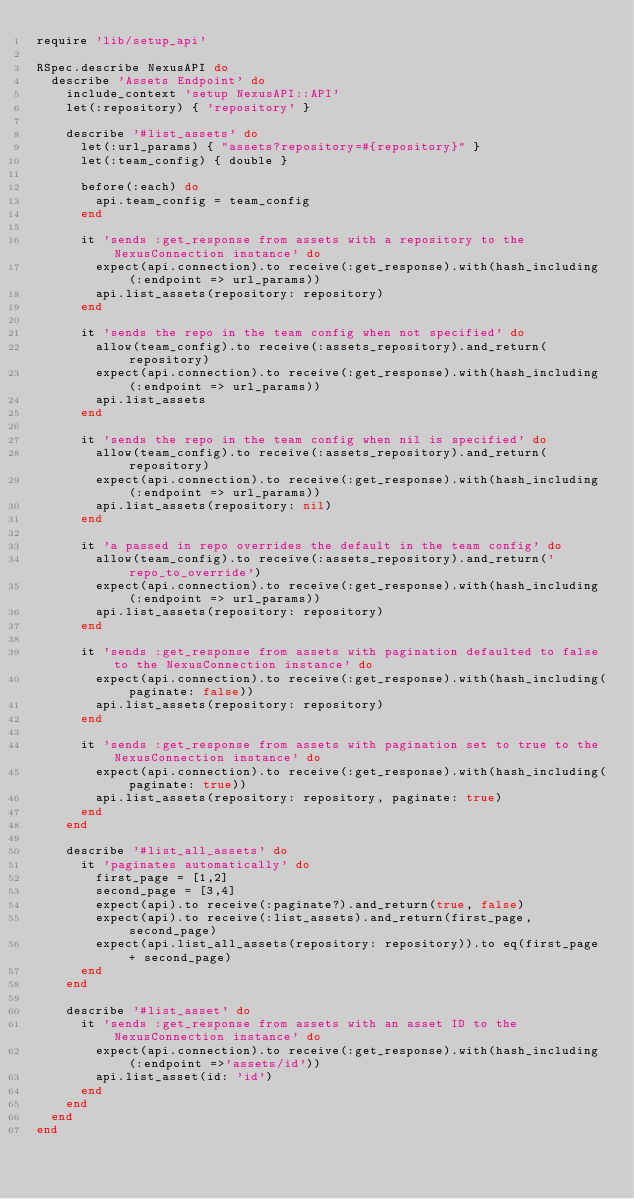<code> <loc_0><loc_0><loc_500><loc_500><_Ruby_>require 'lib/setup_api'

RSpec.describe NexusAPI do
  describe 'Assets Endpoint' do
    include_context 'setup NexusAPI::API'
    let(:repository) { 'repository' }

    describe '#list_assets' do
      let(:url_params) { "assets?repository=#{repository}" }
      let(:team_config) { double }

      before(:each) do
        api.team_config = team_config
      end

      it 'sends :get_response from assets with a repository to the NexusConnection instance' do
        expect(api.connection).to receive(:get_response).with(hash_including(:endpoint => url_params))
        api.list_assets(repository: repository)
      end

      it 'sends the repo in the team config when not specified' do
        allow(team_config).to receive(:assets_repository).and_return(repository)
        expect(api.connection).to receive(:get_response).with(hash_including(:endpoint => url_params))
        api.list_assets
      end

      it 'sends the repo in the team config when nil is specified' do
        allow(team_config).to receive(:assets_repository).and_return(repository)
        expect(api.connection).to receive(:get_response).with(hash_including(:endpoint => url_params))
        api.list_assets(repository: nil)
      end

      it 'a passed in repo overrides the default in the team config' do
        allow(team_config).to receive(:assets_repository).and_return('repo_to_override')
        expect(api.connection).to receive(:get_response).with(hash_including(:endpoint => url_params))
        api.list_assets(repository: repository)
      end

      it 'sends :get_response from assets with pagination defaulted to false to the NexusConnection instance' do
        expect(api.connection).to receive(:get_response).with(hash_including(paginate: false))
        api.list_assets(repository: repository)
      end

      it 'sends :get_response from assets with pagination set to true to the NexusConnection instance' do
        expect(api.connection).to receive(:get_response).with(hash_including(paginate: true))
        api.list_assets(repository: repository, paginate: true)
      end
    end

    describe '#list_all_assets' do
      it 'paginates automatically' do
        first_page = [1,2]
        second_page = [3,4]
        expect(api).to receive(:paginate?).and_return(true, false)
        expect(api).to receive(:list_assets).and_return(first_page, second_page)
        expect(api.list_all_assets(repository: repository)).to eq(first_page + second_page)
      end
    end

    describe '#list_asset' do
      it 'sends :get_response from assets with an asset ID to the NexusConnection instance' do
        expect(api.connection).to receive(:get_response).with(hash_including(:endpoint =>'assets/id'))
        api.list_asset(id: 'id')
      end
    end
  end
end</code> 